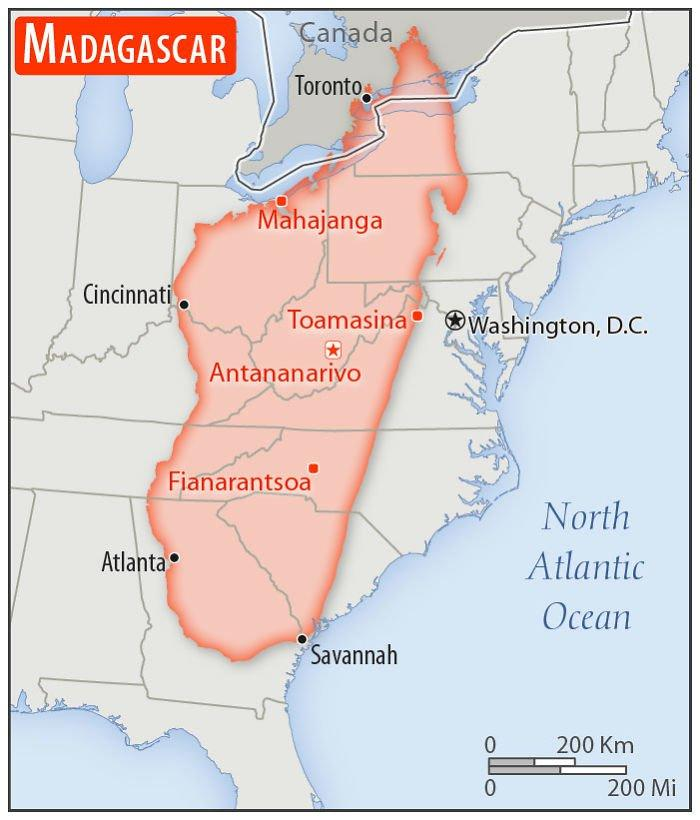Specify some key components in this picture. The North Atlantic Ocean is the water body that lies to the east of Washington, D.C. The location to the west of Toamasina on the map is Cincinnati. There are three countries present in the map. There are four places that are written in red color. In this map, a place lies to the east of Toamasina. The place is Washington, D.C., which is known for its political and cultural significance. 